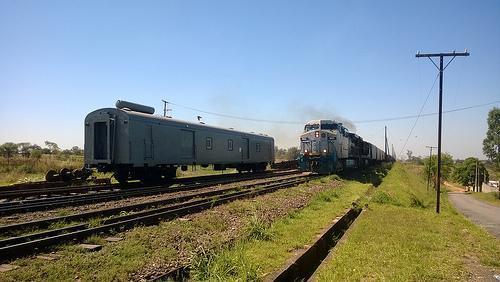How many trains are there?
Give a very brief answer. 2. How many telephone poles are there?
Give a very brief answer. 2. 